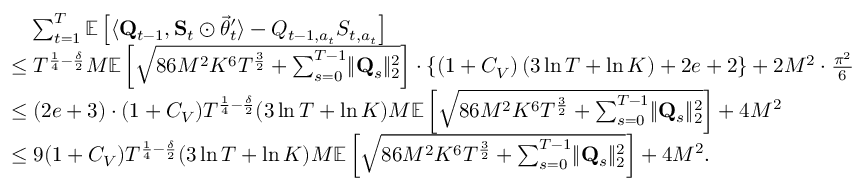<formula> <loc_0><loc_0><loc_500><loc_500>\begin{array} { r l } & { \quad \sum _ { t = 1 } ^ { T } \mathbb { E } \left [ \langle \mathbf Q _ { t - 1 } , \mathbf S _ { t } \odot \vec { \theta } _ { t } ^ { \prime } \rangle - Q _ { t - 1 , a _ { t } } S _ { t , a _ { t } } \right ] } \\ & { \leq T ^ { \frac { 1 } { 4 } - \frac { \delta } { 2 } } M \mathbb { E } \left [ \sqrt { 8 6 M ^ { 2 } K ^ { 6 } T ^ { \frac { 3 } { 2 } } + \sum _ { s = 0 } ^ { T - 1 } \| \mathbf Q _ { s } \| _ { 2 } ^ { 2 } } \right ] \cdot \left \{ \left ( 1 + C _ { V } \right ) \left ( 3 \ln T + \ln K \right ) + 2 e + 2 \right \} + 2 M ^ { 2 } \cdot \frac { \pi ^ { 2 } } 6 } \\ & { \leq ( 2 e + 3 ) \cdot ( 1 + C _ { V } ) T ^ { \frac { 1 } { 4 } - \frac { \delta } { 2 } } ( 3 \ln T + \ln K ) M \mathbb { E } \left [ \sqrt { 8 6 M ^ { 2 } K ^ { 6 } T ^ { \frac { 3 } { 2 } } + \sum _ { s = 0 } ^ { T - 1 } \| \mathbf Q _ { s } \| _ { 2 } ^ { 2 } } \right ] + 4 M ^ { 2 } } \\ & { \leq 9 ( 1 + C _ { V } ) T ^ { \frac { 1 } { 4 } - \frac { \delta } { 2 } } ( 3 \ln T + \ln K ) M \mathbb { E } \left [ \sqrt { 8 6 M ^ { 2 } K ^ { 6 } T ^ { \frac { 3 } { 2 } } + \sum _ { s = 0 } ^ { T - 1 } \| \mathbf Q _ { s } \| _ { 2 } ^ { 2 } } \right ] + 4 M ^ { 2 } . } \end{array}</formula> 